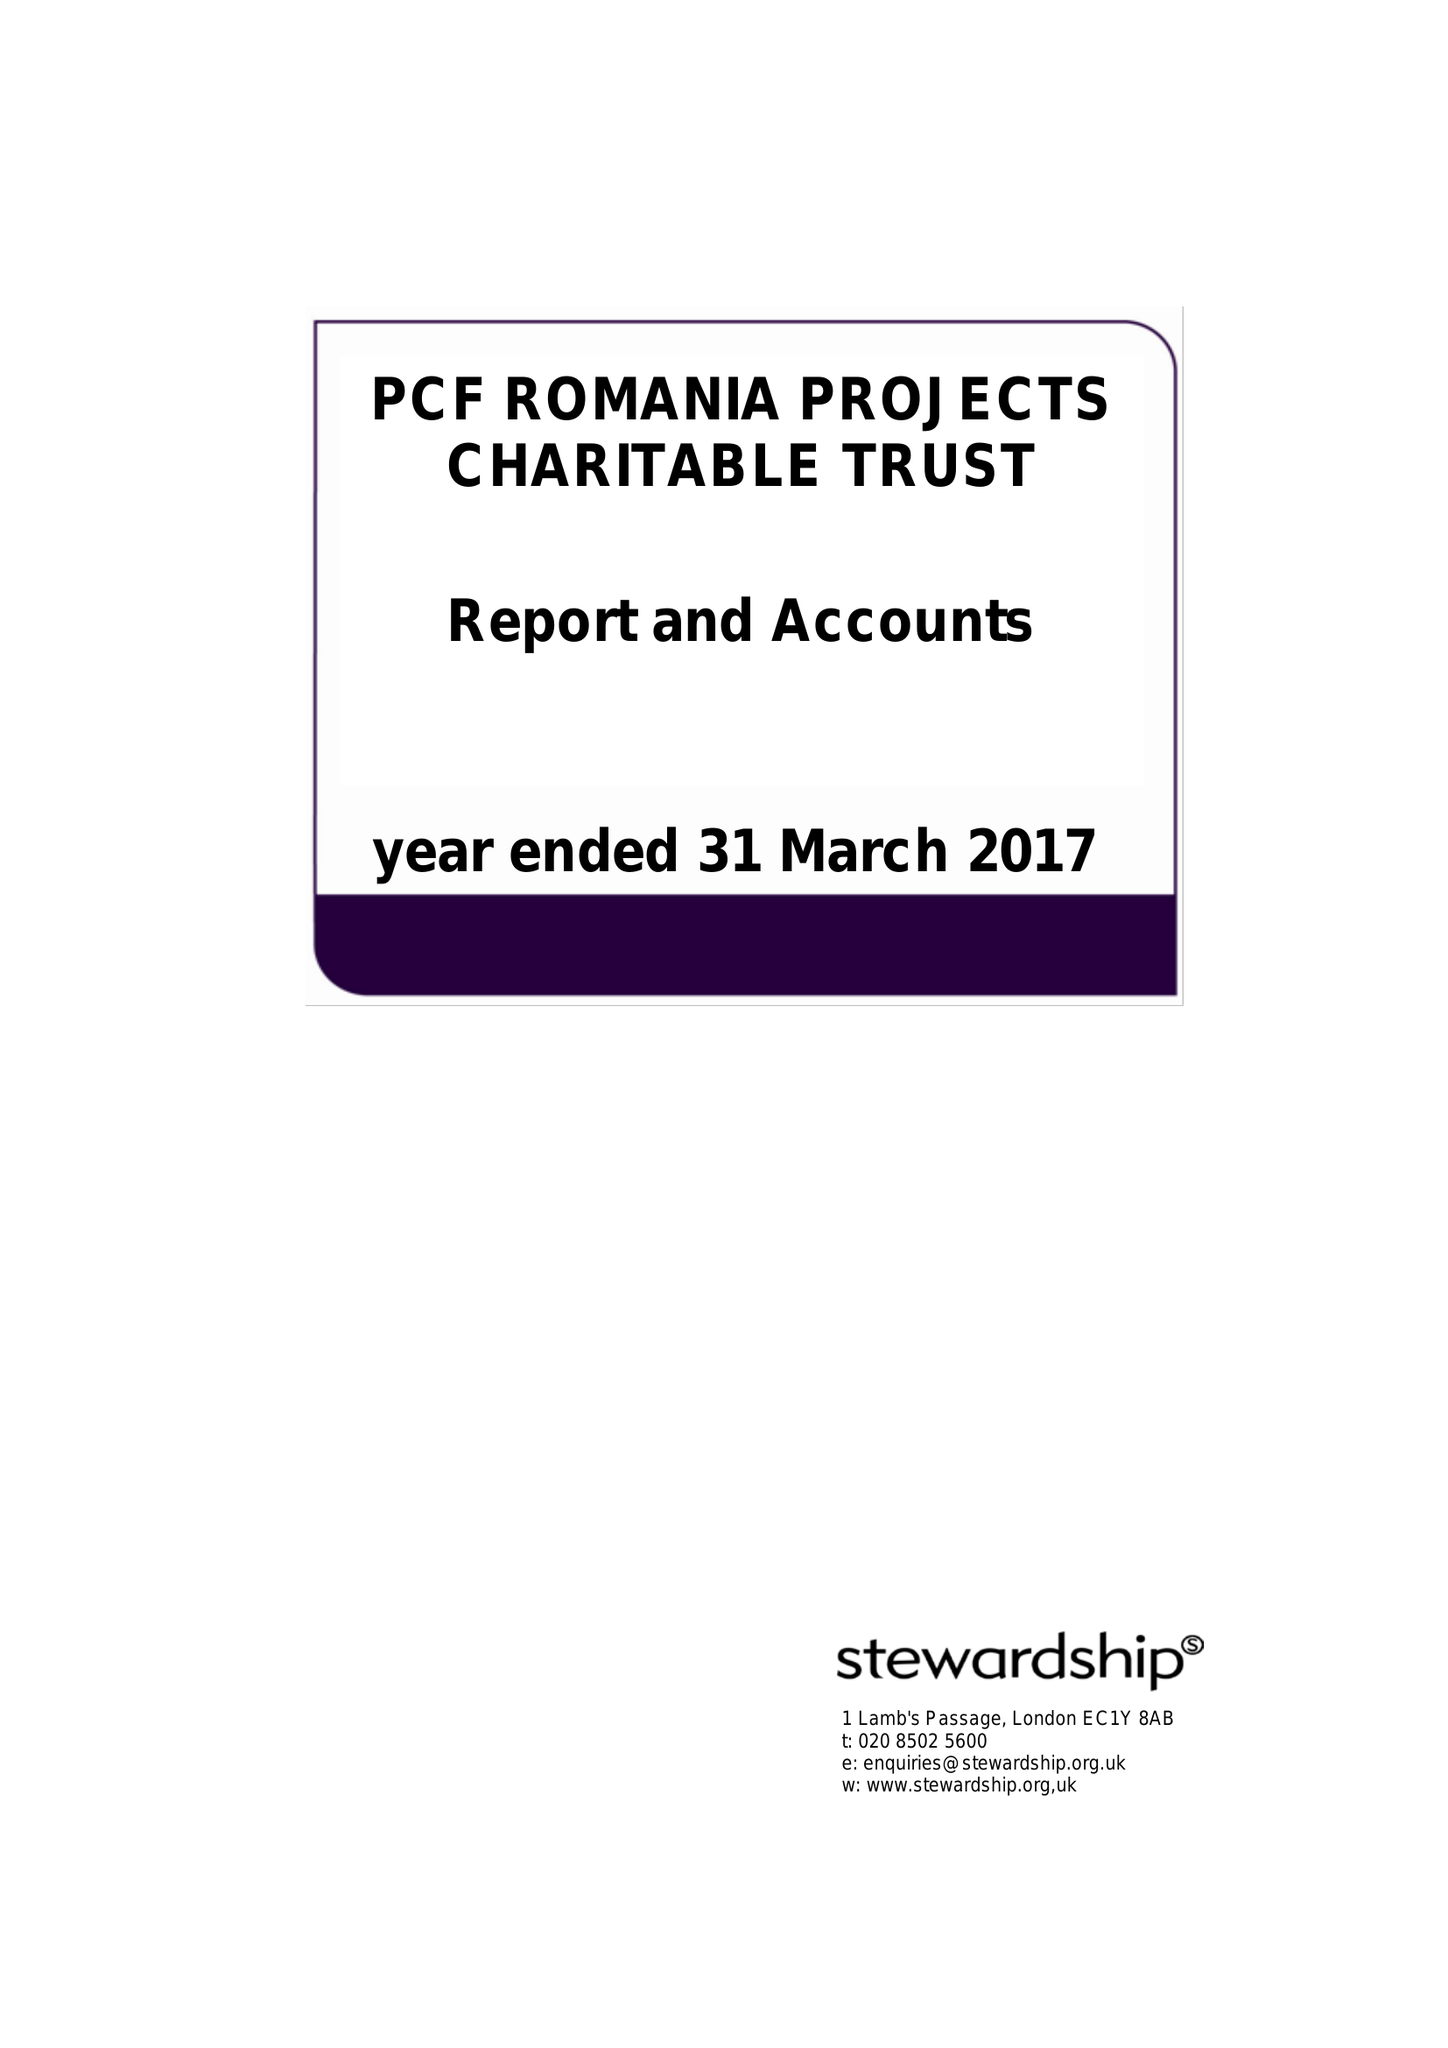What is the value for the address__street_line?
Answer the question using a single word or phrase. 2 THORNBURY COURT 